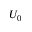Convert formula to latex. <formula><loc_0><loc_0><loc_500><loc_500>U _ { 0 }</formula> 